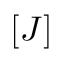Convert formula to latex. <formula><loc_0><loc_0><loc_500><loc_500>[ J ]</formula> 